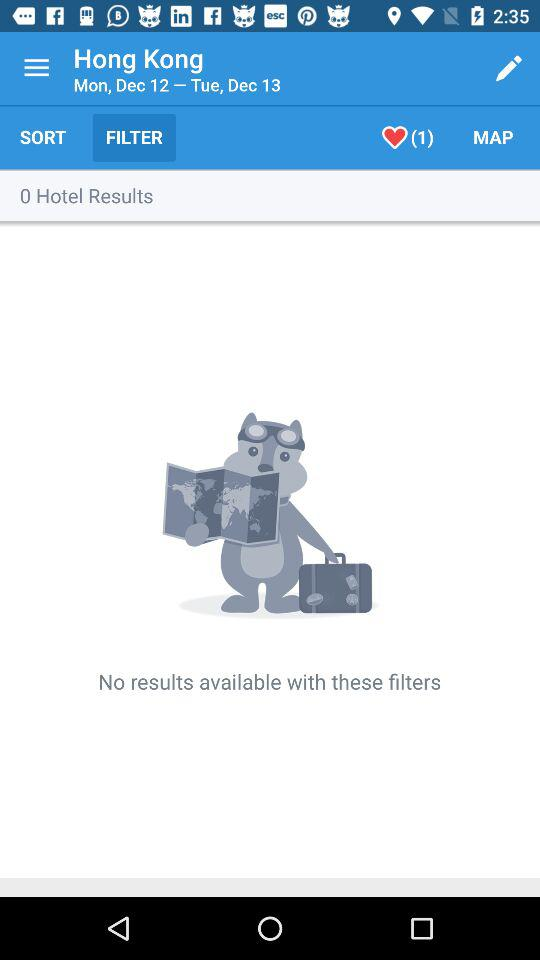What is the current location? The current location is Hong Kong. 